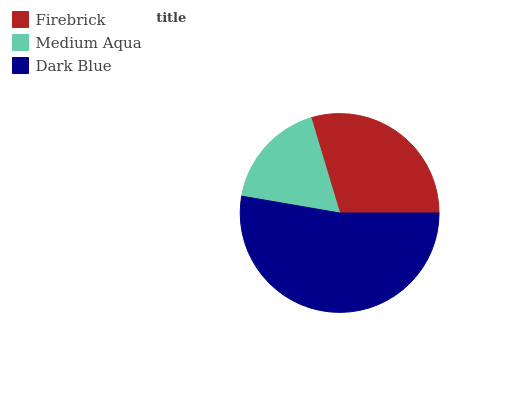Is Medium Aqua the minimum?
Answer yes or no. Yes. Is Dark Blue the maximum?
Answer yes or no. Yes. Is Dark Blue the minimum?
Answer yes or no. No. Is Medium Aqua the maximum?
Answer yes or no. No. Is Dark Blue greater than Medium Aqua?
Answer yes or no. Yes. Is Medium Aqua less than Dark Blue?
Answer yes or no. Yes. Is Medium Aqua greater than Dark Blue?
Answer yes or no. No. Is Dark Blue less than Medium Aqua?
Answer yes or no. No. Is Firebrick the high median?
Answer yes or no. Yes. Is Firebrick the low median?
Answer yes or no. Yes. Is Dark Blue the high median?
Answer yes or no. No. Is Medium Aqua the low median?
Answer yes or no. No. 